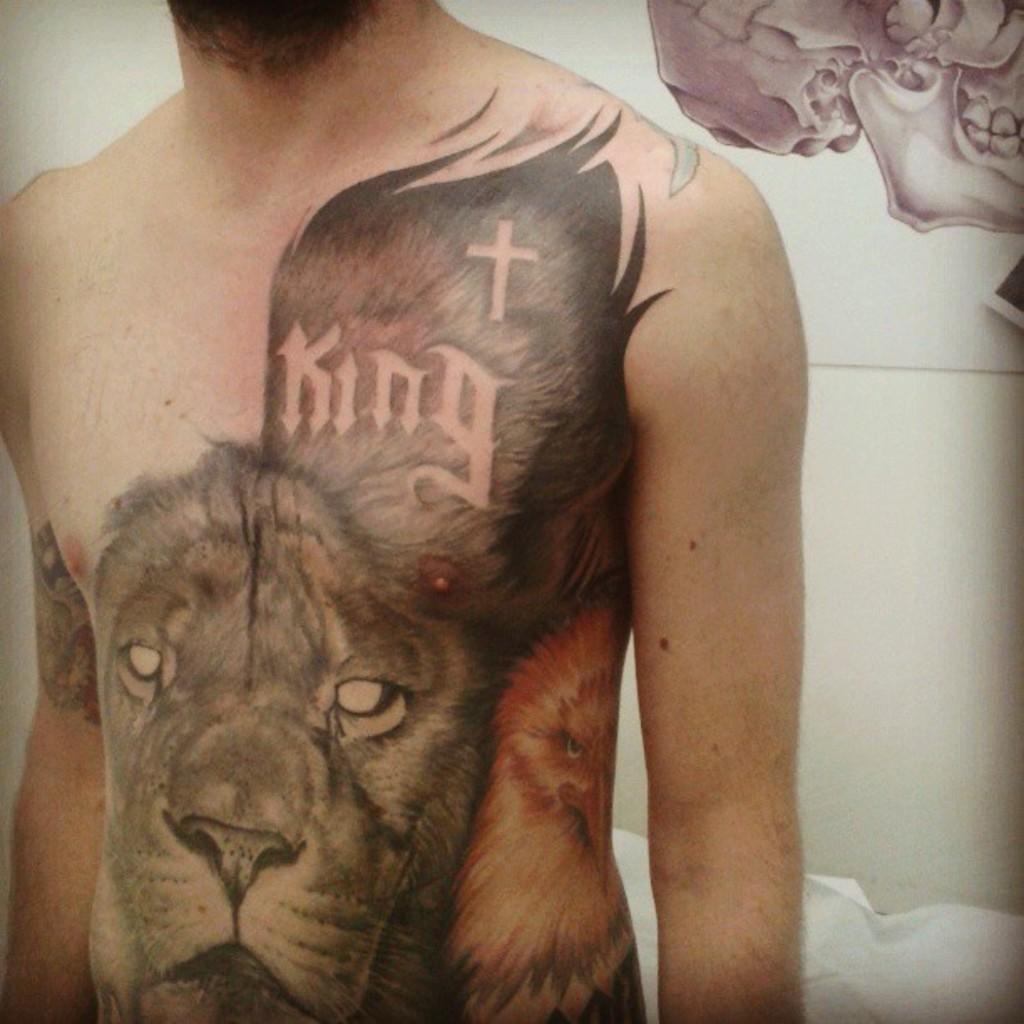How would you summarize this image in a sentence or two? In this picture we can see a man with the tattoos. Behind the man, it looks like a painting on the wall. 